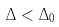<formula> <loc_0><loc_0><loc_500><loc_500>\Delta < \Delta _ { 0 }</formula> 